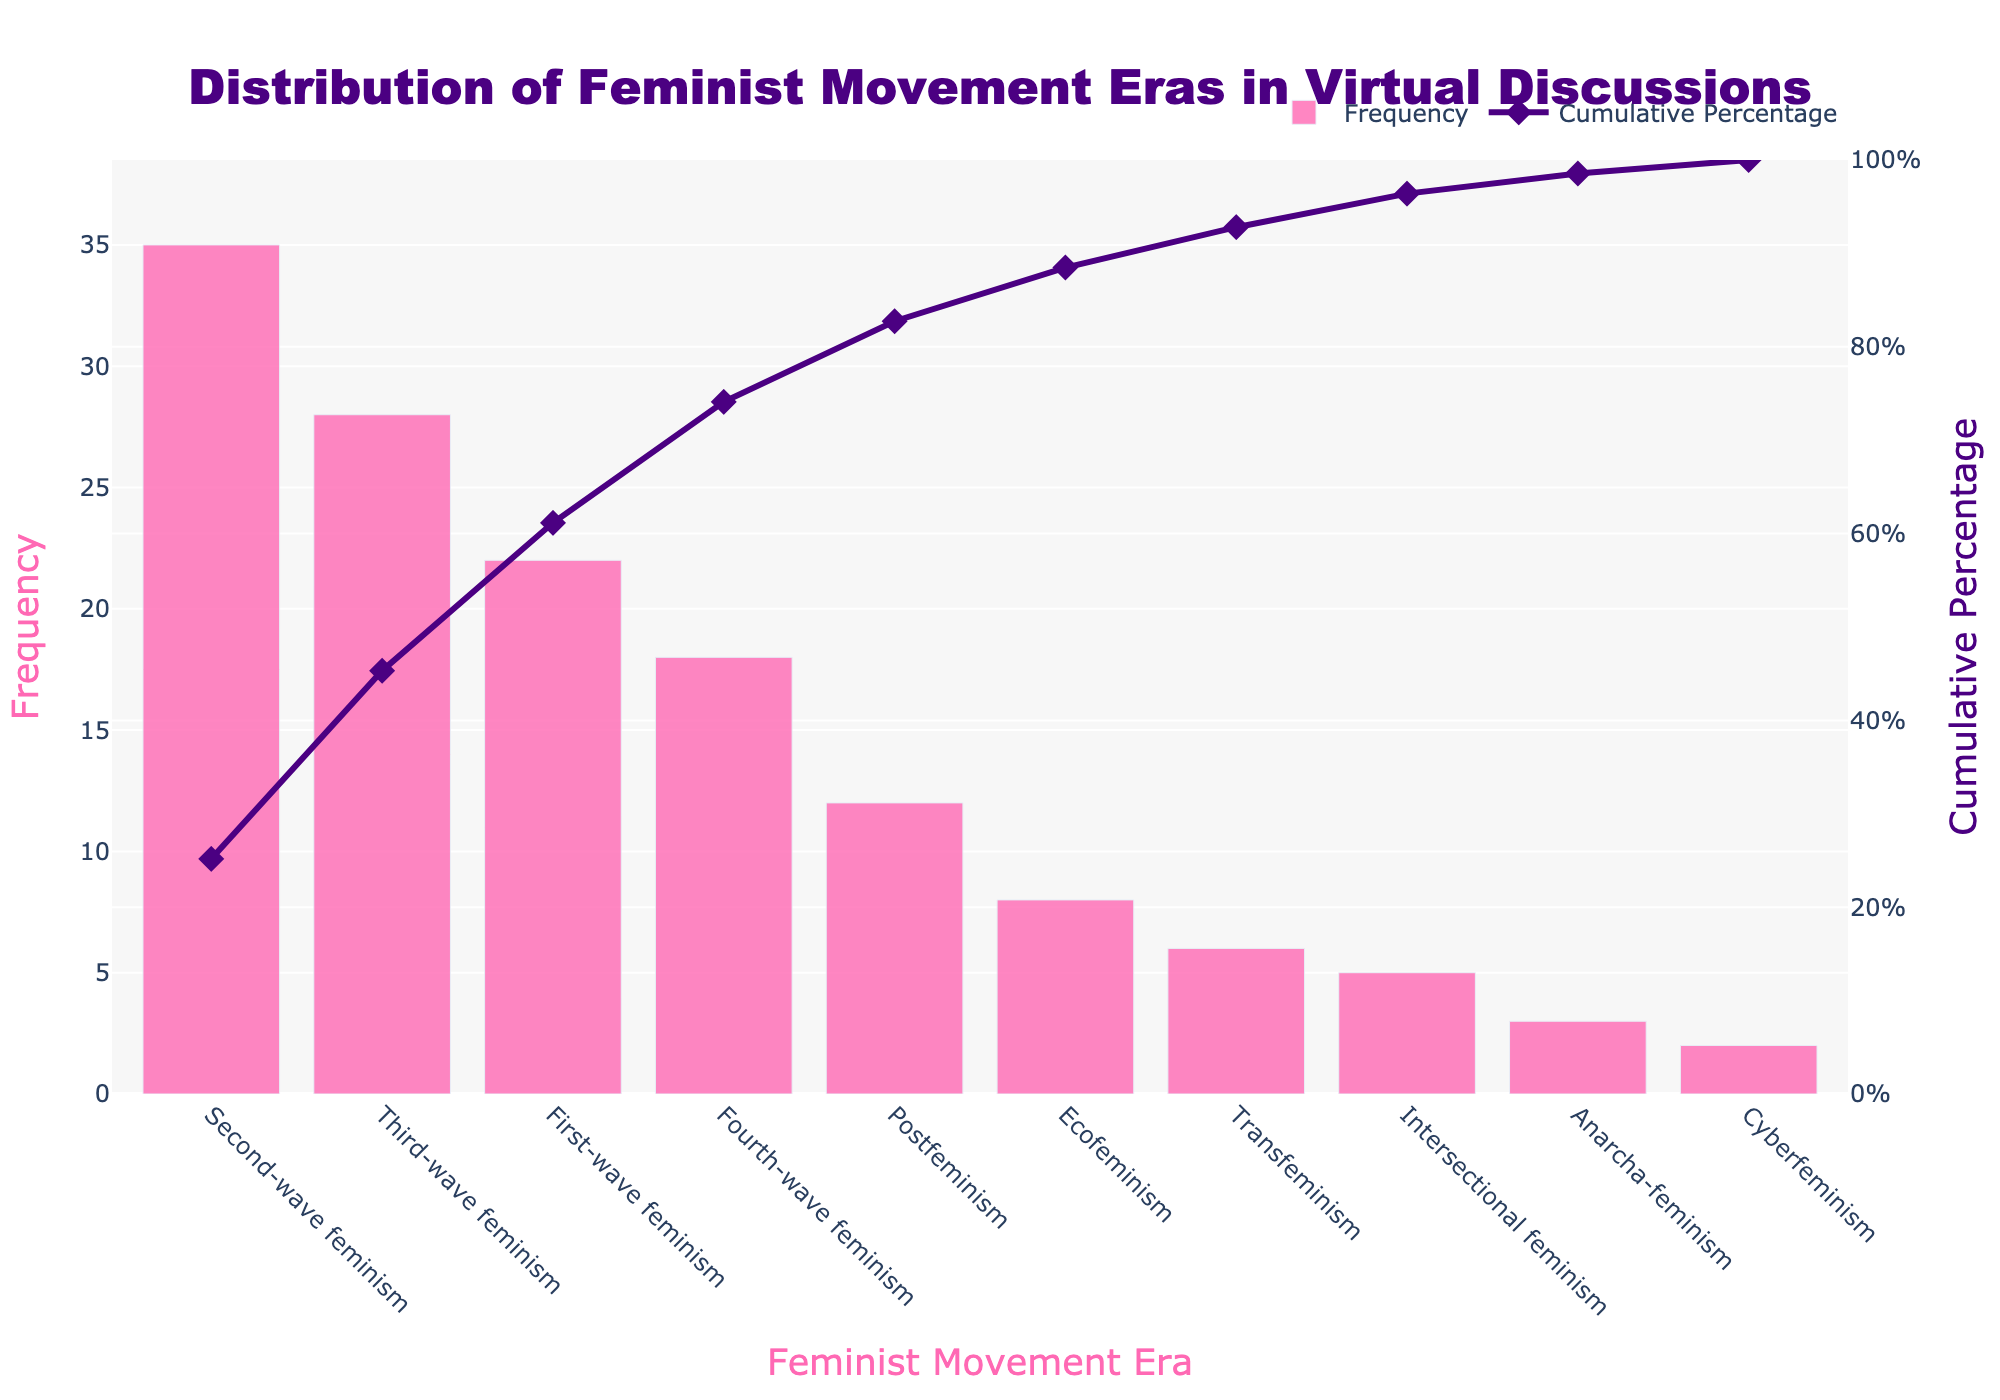What is the title of the figure? The title is usually located at the top of the figure. Here, it reads 'Distribution of Feminist Movement Eras in Virtual Discussions'.
Answer: Distribution of Feminist Movement Eras in Virtual Discussions How many eras have their frequencies shown in the figure? Count the number of bars or distinct eras listed along the x-axis of the bar chart. There are 10 bars/eras.
Answer: 10 Which feminist movement era has the highest frequency in virtual discussions? Look for the bar that is the tallest in the bar chart, which represents the highest frequency. Here, it is 'Second-wave feminism' with a frequency of 35.
Answer: Second-wave feminism What is the cumulative percentage after 'Third-wave feminism'? Find the cumulative percentage value corresponding to 'Third-wave feminism' on the line chart. The cumulative percentage is just over 70%.
Answer: Just over 70% What's the difference in frequency between 'First-wave feminism' and 'Fourth-wave feminism'? Find the frequency values of 'First-wave feminism' (22) and 'Fourth-wave feminism' (18), then subtract the smaller from the larger. 22 - 18 = 4
Answer: 4 What color is used for the bars representing the frequency of different eras? Describe the color of the bars as observed in the figure. Here, the bars are colored pink.
Answer: Pink Which era has the lowest frequency in the virtual discussions? Identify the shortest bar in the bar chart, which has the lowest frequency. 'Cyberfeminism' has the lowest frequency of 2.
Answer: Cyberfeminism What is the frequency of 'Ecofeminism'? Observe the height of the bar corresponding to 'Ecofeminism', which shows a frequency of 8.
Answer: 8 By what percentage does the cumulative percentage increase from 'Third-wave feminism' to 'First-wave feminism'? Find the cumulative percentage at 'Third-wave feminism' (around 73.17%) and 'First-wave feminism' (a bit over 96%), then calculate the difference. 96 - 73.17 = ~22.83%
Answer: ~22.83% Which era reaches the 50% cumulative percentage mark? Observe the point on the cumulative percentage line that crosses the 50% mark; it is around 'Third-wave feminism'
Answer: Third-wave feminism 